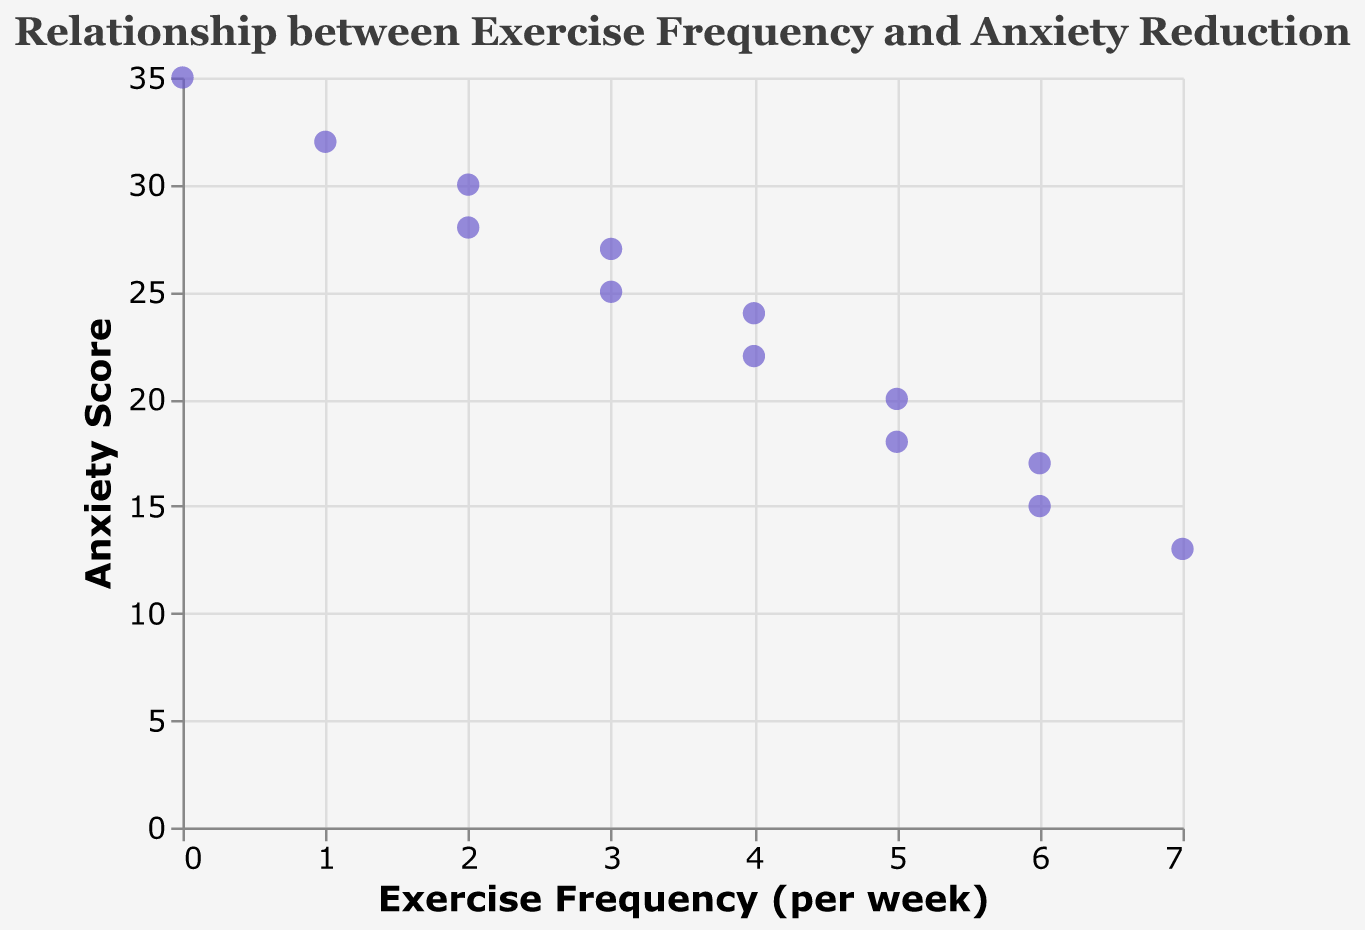What is the title of the figure? The title of the figure can be found at the top and it reads "Relationship between Exercise Frequency and Anxiety Reduction".
Answer: Relationship between Exercise Frequency and Anxiety Reduction How many data points are displayed in the scatter plot? Count each circle representing a data point on the scatter plot. There are 13 data points displayed.
Answer: 13 What is the anxiety score when the exercise frequency is 0 times per week? Locate the circle on the scatter plot where the x-axis value is 0 and read the corresponding y-axis value, which is the anxiety score of 35.
Answer: 35 What is the lowest anxiety score recorded in the scatter plot? Identify the lowest y-axis value among all the data points, which is 13.
Answer: 13 What is the color and size of the data points in the scatter plot? The data points in the scatter plot are colored in purple and the size appears to be medium-sized, specifically sized at 80.
Answer: Purple, Medium (80) How does the anxiety score change as the exercise frequency increases from 3 to 4 times per week? Look at the data points where the x-axis value is 3 and compare them to the ones where the x-axis value is 4. The anxiety scores reduce from 27 and 25 to 24 and 22 respectively.
Answer: Decreases Which exercise frequency shows the greatest reduction in anxiety score compared to no exercise? Compare the anxiety score at 0 frequency (35) to other frequencies. The greatest reduction is seen at an exercise frequency of 7 times per week where the anxiety score is 13.
Answer: 7 times What is the average anxiety score for exercise frequencies of 5 times per week? Identify the y-axis values for x=5 (20 and 18), sum them up to get 38, and divide by the number of data points (2) to get the average. 38 / 2 = 19.
Answer: 19 Is there a general trend visible between exercise frequency and anxiety score? Examine the overall direction of the data points from left (low exercise frequency) to right (high exercise frequency). The anxiety score generally decreases as exercise frequency increases, showing a negative correlation.
Answer: Negative correlation Which frequency per week has a consistent reduction in anxiety score as seen from the scatter plot? Look for data points with consistent reduction in anxiety score, exercise frequencies of 3, 4, 5, and 6 times per week all show consistent reduction without any increase.
Answer: 3, 4, 5, 6 times per week 